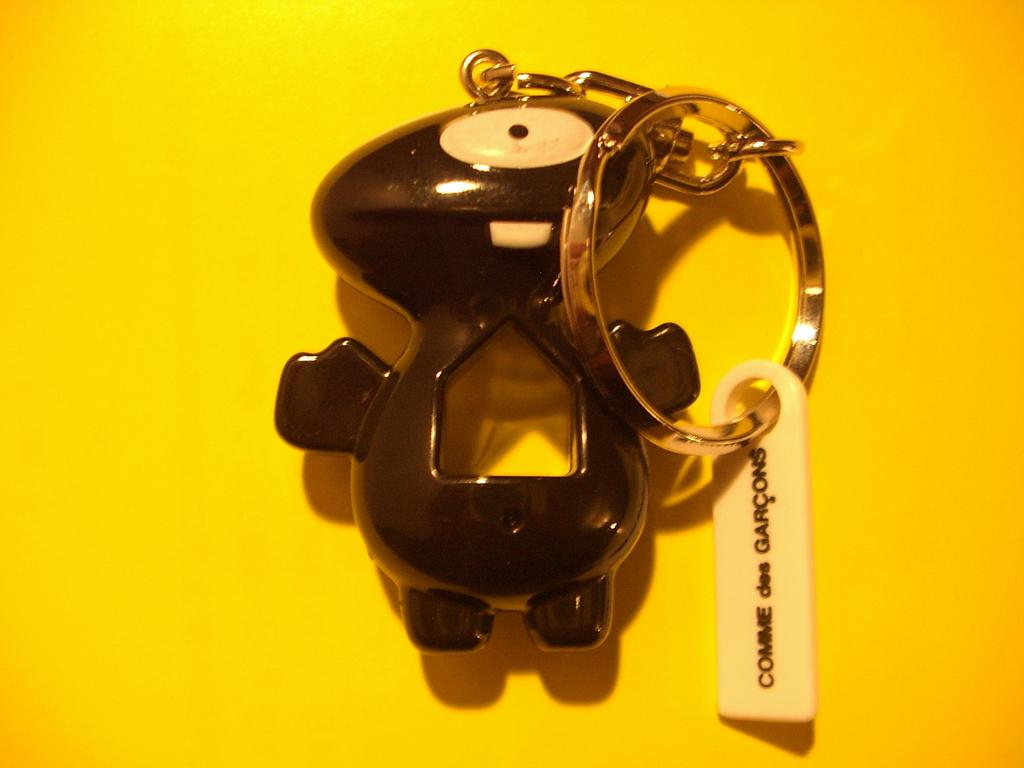What object can be seen in the image that is typically used for holding keys? There is a key chain in the image. What other object is present in the image besides the key chain? There is a toy in the image. What is written or printed on the key chain? There is text on the key chain. What color is the background of the image? The background color is yellow. How does the pest contribute to the functionality of the key chain in the image? There is no pest present in the image, so it cannot contribute to the functionality of the key chain. 